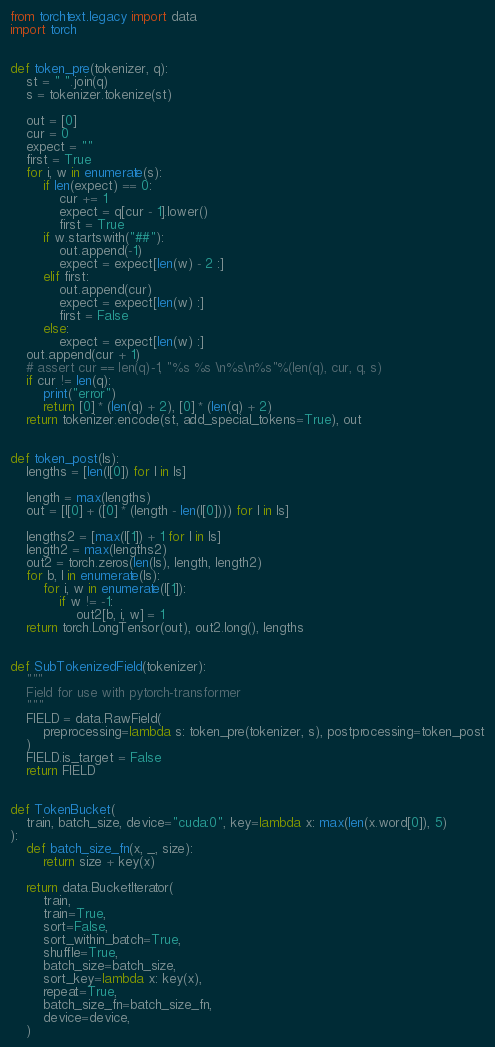<code> <loc_0><loc_0><loc_500><loc_500><_Python_>from torchtext.legacy import data
import torch


def token_pre(tokenizer, q):
    st = " ".join(q)
    s = tokenizer.tokenize(st)

    out = [0]
    cur = 0
    expect = ""
    first = True
    for i, w in enumerate(s):
        if len(expect) == 0:
            cur += 1
            expect = q[cur - 1].lower()
            first = True
        if w.startswith("##"):
            out.append(-1)
            expect = expect[len(w) - 2 :]
        elif first:
            out.append(cur)
            expect = expect[len(w) :]
            first = False
        else:
            expect = expect[len(w) :]
    out.append(cur + 1)
    # assert cur == len(q)-1, "%s %s \n%s\n%s"%(len(q), cur, q, s)
    if cur != len(q):
        print("error")
        return [0] * (len(q) + 2), [0] * (len(q) + 2)
    return tokenizer.encode(st, add_special_tokens=True), out


def token_post(ls):
    lengths = [len(l[0]) for l in ls]

    length = max(lengths)
    out = [l[0] + ([0] * (length - len(l[0]))) for l in ls]

    lengths2 = [max(l[1]) + 1 for l in ls]
    length2 = max(lengths2)
    out2 = torch.zeros(len(ls), length, length2)
    for b, l in enumerate(ls):
        for i, w in enumerate(l[1]):
            if w != -1:
                out2[b, i, w] = 1
    return torch.LongTensor(out), out2.long(), lengths


def SubTokenizedField(tokenizer):
    """
    Field for use with pytorch-transformer
    """
    FIELD = data.RawField(
        preprocessing=lambda s: token_pre(tokenizer, s), postprocessing=token_post
    )
    FIELD.is_target = False
    return FIELD


def TokenBucket(
    train, batch_size, device="cuda:0", key=lambda x: max(len(x.word[0]), 5)
):
    def batch_size_fn(x, _, size):
        return size + key(x)

    return data.BucketIterator(
        train,
        train=True,
        sort=False,
        sort_within_batch=True,
        shuffle=True,
        batch_size=batch_size,
        sort_key=lambda x: key(x),
        repeat=True,
        batch_size_fn=batch_size_fn,
        device=device,
    )
</code> 